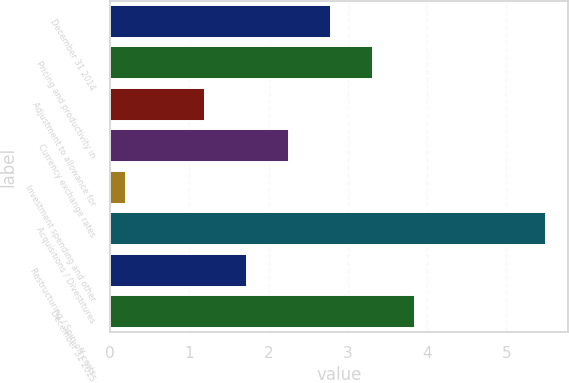Convert chart to OTSL. <chart><loc_0><loc_0><loc_500><loc_500><bar_chart><fcel>December 31 2014<fcel>Pricing and productivity in<fcel>Adjustment to allowance for<fcel>Currency exchange rates<fcel>Investment spending and other<fcel>Acquisitions / Divestitures<fcel>Restructuring / Spin-off costs<fcel>December 31 2015<nl><fcel>2.79<fcel>3.32<fcel>1.2<fcel>2.26<fcel>0.2<fcel>5.5<fcel>1.73<fcel>3.85<nl></chart> 